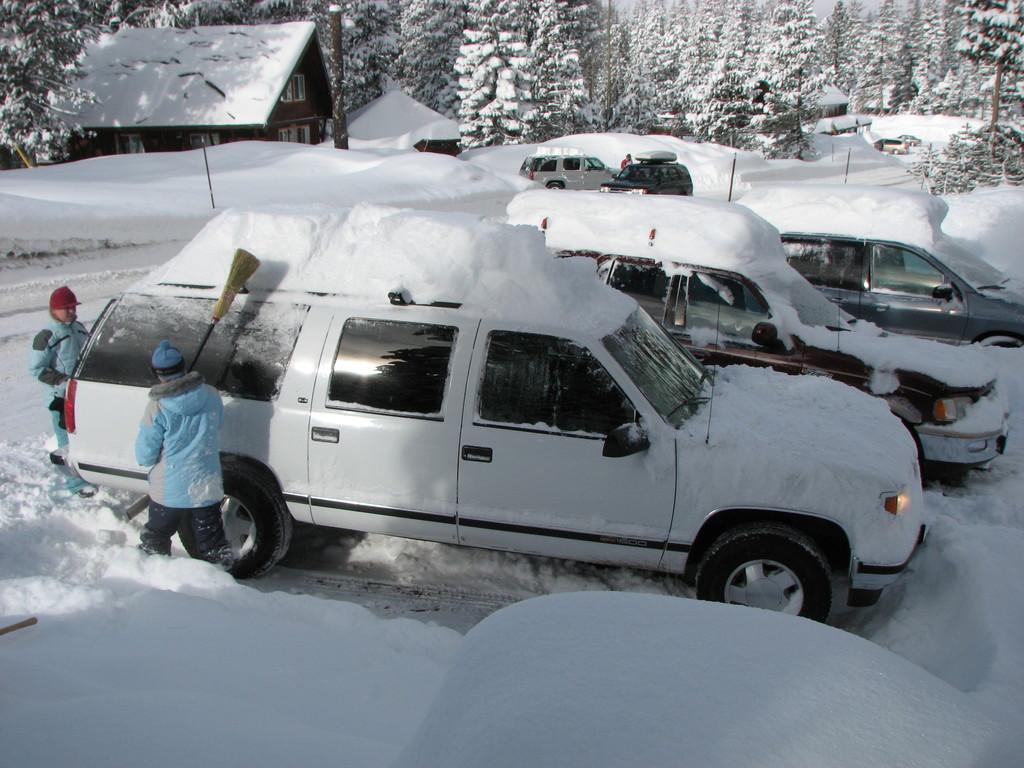What type of objects are on the ground in the image? There are motor vehicles on the ground in the image. What are the persons holding in their hands? The persons are holding brooms in their hands. What structures can be seen in the image? There are buildings in the image. What type of vegetation is present in the image? There are trees in the image. What is visible in the background of the image? The sky is visible in the image. What time of day is represented by the hour in the image? There is no hour present in the image, as it is a visual representation and not a clock. Can you describe the girl wearing a scarf in the image? There is no girl or scarf present in the image. 